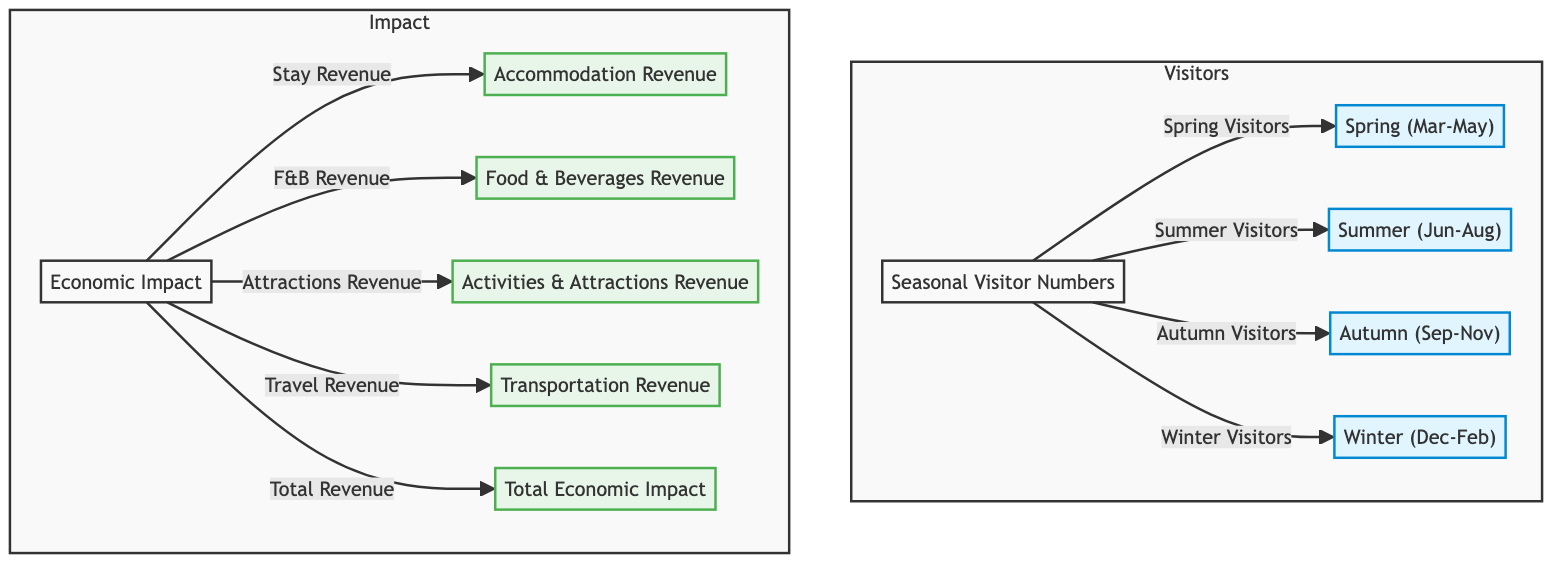What are the four seasons represented in the diagram? The diagram displays four seasons categorized under Seasonal Visitor Numbers: Spring, Summer, Autumn, and Winter. These nodes represent the different periods during which visitors come to the area.
Answer: Spring, Summer, Autumn, Winter What economic impact category is related to accommodation? The economic impact section includes a node for Accommodation Revenue, which relates specifically to the revenue generated from people staying in accommodations while visiting.
Answer: Accommodation Revenue How many types of economic impact are shown in the diagram? The diagram displays five types of economic impact related to local tourism: Accommodation Revenue, Food & Beverages Revenue, Activities & Attractions Revenue, Transportation Revenue, and Total Economic Impact, indicating a robust measurement of tourism's financial effects.
Answer: Five Which season is expected to have the highest number of visitors? Summer is typically known for having the highest number of visitors in many regions, especially in tourist areas, though the diagram does not provide specific numbers, it is generally accepted knowledge.
Answer: Summer What total economic impact category connects to all revenue sources? The Total Economic Impact node summarizes all revenues obtained from various sources, showing how the individual revenue streams contribute to the overall economic benefit from tourism in the municipality.
Answer: Total Economic Impact Which nodes in the diagram represent the subcategory of revenue sources impacting economic impact? The revenue sources include Accommodation Revenue, Food & Beverages Revenue, Activities & Attractions Revenue, and Transportation Revenue, all of which are directly related to the economic impact of local tourism.
Answer: Accommodation Revenue, Food & Beverages Revenue, Activities & Attractions Revenue, Transportation Revenue How do visitor numbers relate to economic impact? Visitor numbers, categorized by season, indicate the flow of tourists in each period, which directly impacts economic variables such as revenue from accommodations, food and beverages, and activities, creating a chain of economic influence in the municipality.
Answer: Visitor Numbers impact Economic Impact Which season comes before autumn in the diagram? According to the seasonal order represented in the diagram, Summer comes right before Autumn, indicating the transition from mid-year to the fall season in terms of visitor flow.
Answer: Summer 